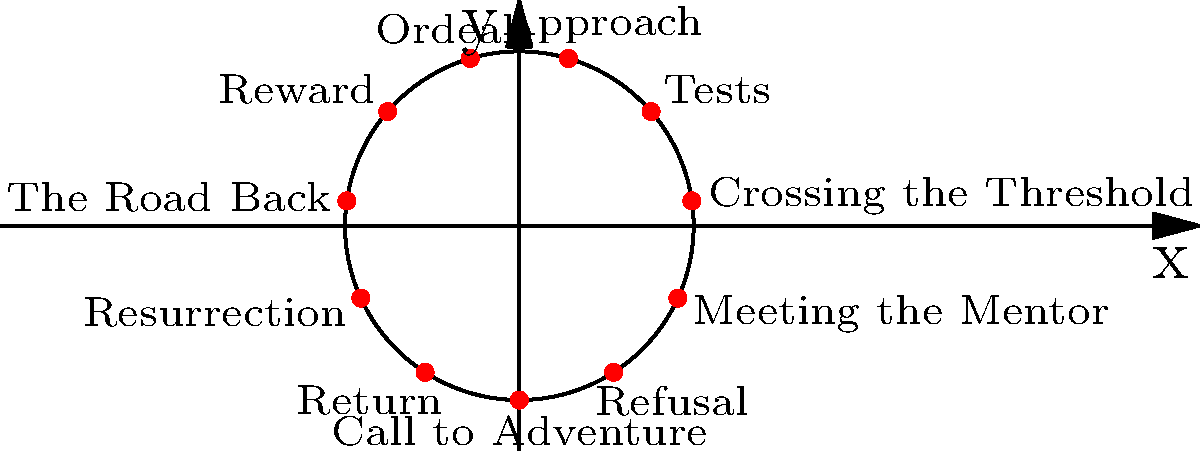In the circular coordinate plane representing the stages of a hero's journey, which quadrant contains the "Ordeal" stage? How might this positioning influence the dramatic arc of an improvised performance? To answer this question, let's break it down step-by-step:

1. Observe the circular coordinate plane:
   The plane is divided into four quadrants by the x and y axes.

2. Identify the quadrants:
   - Quadrant I: Upper right (x > 0, y > 0)
   - Quadrant II: Upper left (x < 0, y > 0)
   - Quadrant III: Lower left (x < 0, y < 0)
   - Quadrant IV: Lower right (x > 0, y < 0)

3. Locate the "Ordeal" stage:
   The "Ordeal" stage is positioned in the lower left part of the circle.

4. Determine the quadrant:
   The "Ordeal" stage is in Quadrant III (x < 0, y < 0).

5. Consider the dramatic implications:
   The "Ordeal" being in Quadrant III suggests it occurs after the midpoint of the journey. In improvisation, this positioning could influence the performance by:
   
   a) Indicating that the hero has already faced several challenges (Tests, Approach) before reaching this critical point.
   b) Suggesting that the "Ordeal" is a low point in the hero's journey, both literally (in the lower half of the circle) and figuratively.
   c) Implying that after the "Ordeal," the hero's trajectory will begin to ascend towards resolution and return.

6. Improvisation potential:
   An improv actor could use this positioning to:
   
   a) Build tension gradually through the first half of the performance.
   b) Create a dramatic climax or turning point at the "Ordeal" stage.
   c) Shift the energy and tone of the performance after the "Ordeal," moving towards resolution and growth.
Answer: Quadrant III; it suggests a climactic low point before the hero's ascent to resolution. 